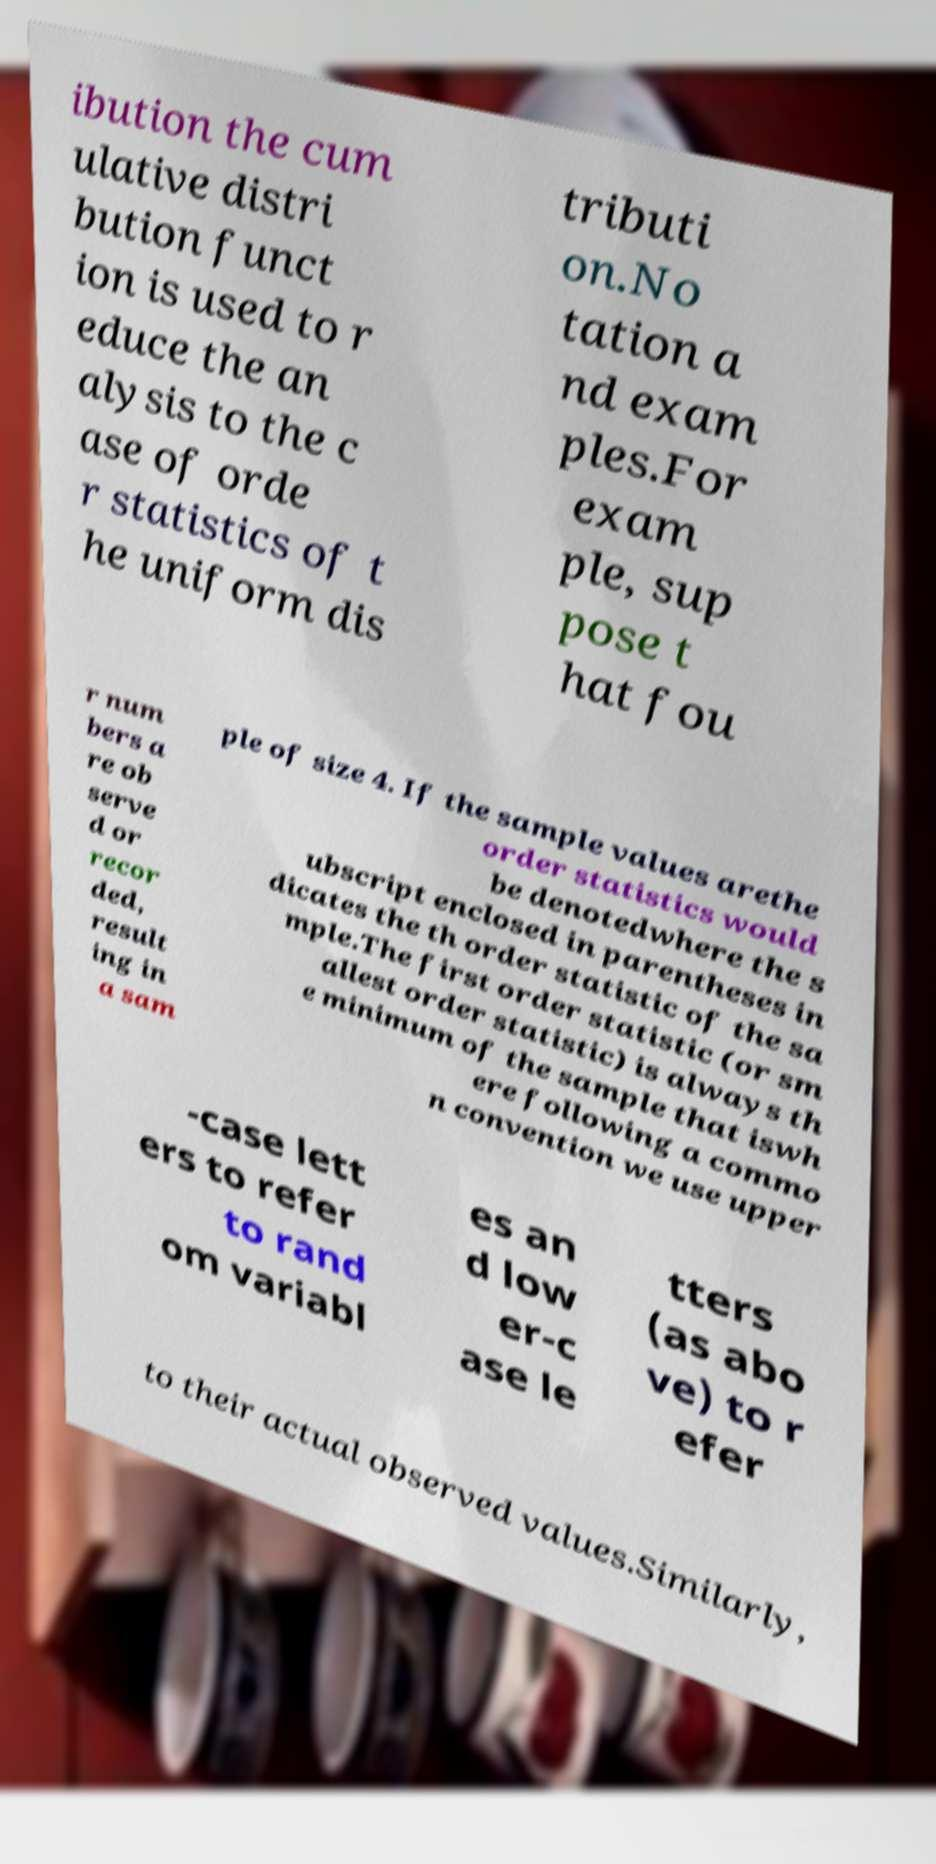Can you read and provide the text displayed in the image?This photo seems to have some interesting text. Can you extract and type it out for me? ibution the cum ulative distri bution funct ion is used to r educe the an alysis to the c ase of orde r statistics of t he uniform dis tributi on.No tation a nd exam ples.For exam ple, sup pose t hat fou r num bers a re ob serve d or recor ded, result ing in a sam ple of size 4. If the sample values arethe order statistics would be denotedwhere the s ubscript enclosed in parentheses in dicates the th order statistic of the sa mple.The first order statistic (or sm allest order statistic) is always th e minimum of the sample that iswh ere following a commo n convention we use upper -case lett ers to refer to rand om variabl es an d low er-c ase le tters (as abo ve) to r efer to their actual observed values.Similarly, 